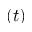Convert formula to latex. <formula><loc_0><loc_0><loc_500><loc_500>( t )</formula> 